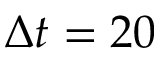Convert formula to latex. <formula><loc_0><loc_0><loc_500><loc_500>\Delta t = 2 0</formula> 